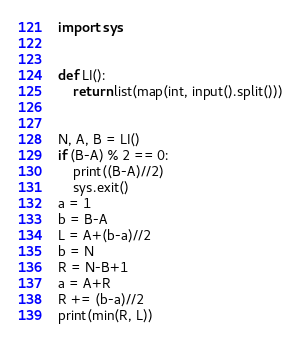<code> <loc_0><loc_0><loc_500><loc_500><_Python_>import sys


def LI():
    return list(map(int, input().split()))


N, A, B = LI()
if (B-A) % 2 == 0:
    print((B-A)//2)
    sys.exit()
a = 1
b = B-A
L = A+(b-a)//2
b = N
R = N-B+1
a = A+R
R += (b-a)//2
print(min(R, L))
</code> 